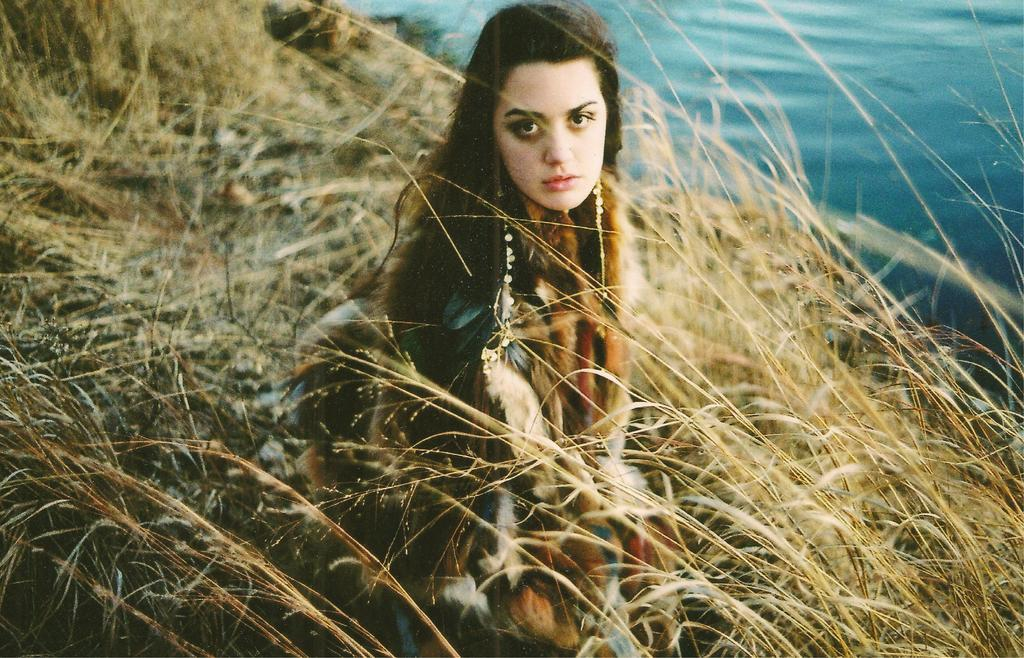Who is the main subject in the image? There is a lady in the image. What can be seen in the background of the image? There is grass and water visible in the background of the image. What statement does the police officer make in the image? There is no police officer present in the image, so no statement can be made. 